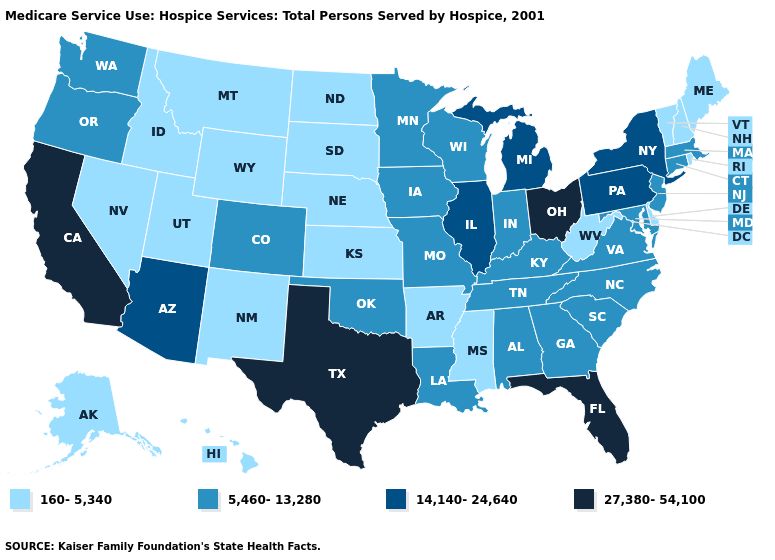What is the value of Mississippi?
Answer briefly. 160-5,340. Does Tennessee have a lower value than Ohio?
Be succinct. Yes. What is the lowest value in the USA?
Keep it brief. 160-5,340. What is the lowest value in the Northeast?
Give a very brief answer. 160-5,340. Does Oregon have a lower value than Alabama?
Write a very short answer. No. What is the value of Colorado?
Answer briefly. 5,460-13,280. What is the highest value in the USA?
Be succinct. 27,380-54,100. Does New Jersey have the same value as Colorado?
Write a very short answer. Yes. Name the states that have a value in the range 14,140-24,640?
Short answer required. Arizona, Illinois, Michigan, New York, Pennsylvania. Name the states that have a value in the range 14,140-24,640?
Short answer required. Arizona, Illinois, Michigan, New York, Pennsylvania. What is the value of Mississippi?
Short answer required. 160-5,340. Which states have the lowest value in the USA?
Quick response, please. Alaska, Arkansas, Delaware, Hawaii, Idaho, Kansas, Maine, Mississippi, Montana, Nebraska, Nevada, New Hampshire, New Mexico, North Dakota, Rhode Island, South Dakota, Utah, Vermont, West Virginia, Wyoming. Among the states that border North Dakota , which have the highest value?
Write a very short answer. Minnesota. Name the states that have a value in the range 14,140-24,640?
Quick response, please. Arizona, Illinois, Michigan, New York, Pennsylvania. Does California have a higher value than Florida?
Keep it brief. No. 